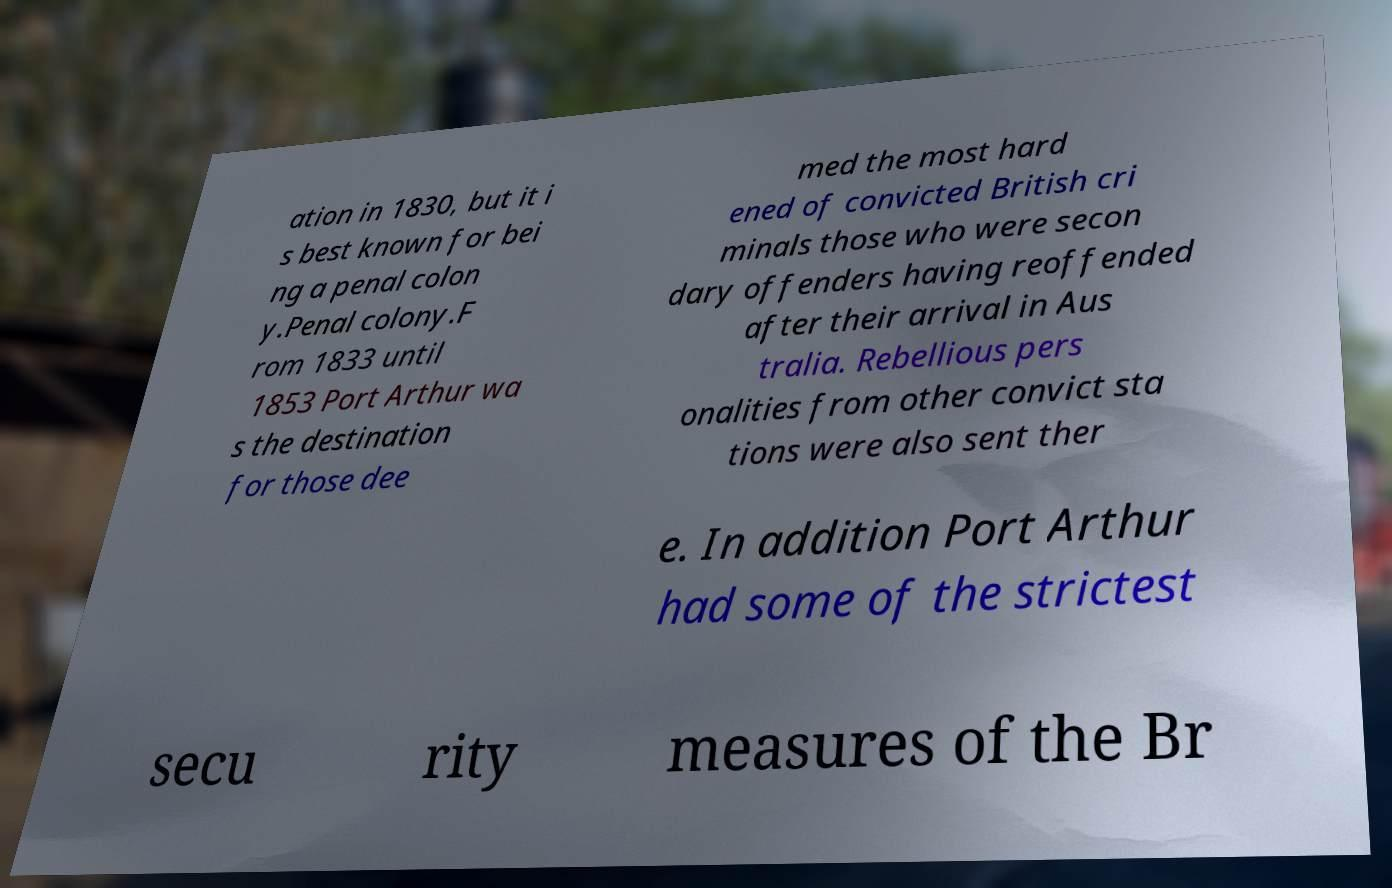What messages or text are displayed in this image? I need them in a readable, typed format. ation in 1830, but it i s best known for bei ng a penal colon y.Penal colony.F rom 1833 until 1853 Port Arthur wa s the destination for those dee med the most hard ened of convicted British cri minals those who were secon dary offenders having reoffended after their arrival in Aus tralia. Rebellious pers onalities from other convict sta tions were also sent ther e. In addition Port Arthur had some of the strictest secu rity measures of the Br 